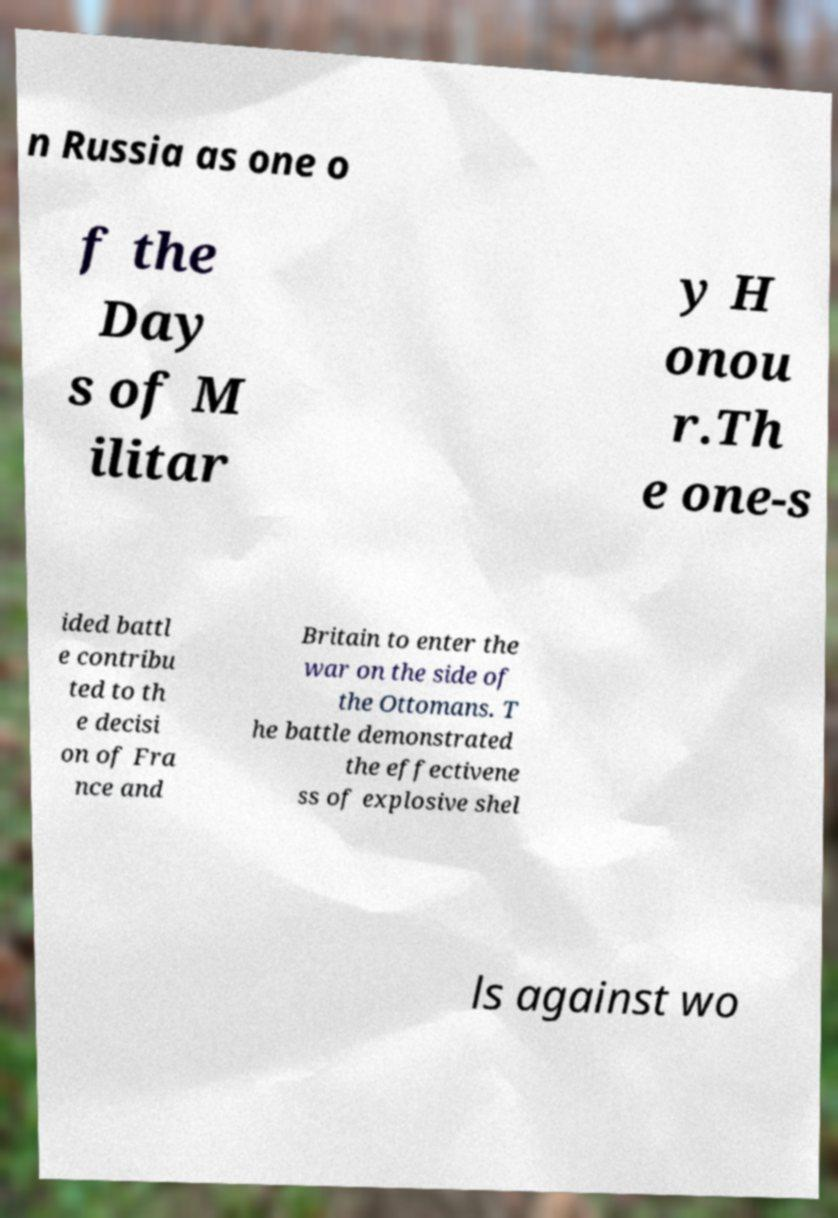Please read and relay the text visible in this image. What does it say? n Russia as one o f the Day s of M ilitar y H onou r.Th e one-s ided battl e contribu ted to th e decisi on of Fra nce and Britain to enter the war on the side of the Ottomans. T he battle demonstrated the effectivene ss of explosive shel ls against wo 